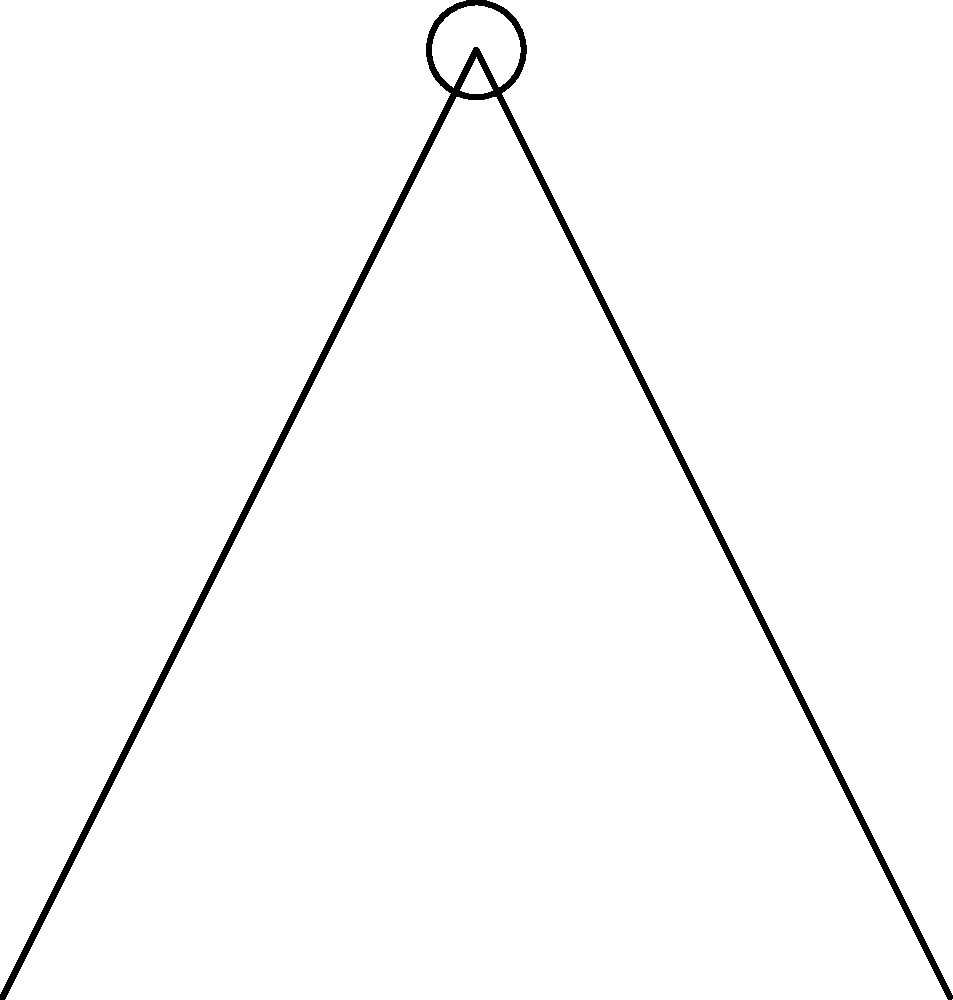As a union leader advocating for worker safety, you're analyzing the biomechanics of manual material handling. In the stick figure illustration, a worker is lifting a load. If the worker's hand force (F) is 300 N, the horizontal distance (L) from the ankles to the hands is 0.5 m, and the vertical distance (h) from the floor to the hands is 1 m, what is the magnitude of the moment about the worker's lower back? To solve this problem, we'll follow these steps:

1. Understand the concept of moment:
   Moment = Force × Perpendicular distance

2. Identify the given information:
   - Hand force (F) = 300 N
   - Horizontal distance (L) = 0.5 m
   - Vertical distance (h) = 1 m

3. Determine the perpendicular distance:
   In this case, the perpendicular distance is the horizontal distance (L) from the ankles to the hands.

4. Calculate the moment:
   Moment = F × L
   Moment = 300 N × 0.5 m
   Moment = 150 N·m

5. Interpret the result:
   The moment about the worker's lower back is 150 N·m, which represents the rotational force acting on the lower back during the lifting task.

This analysis helps in understanding the stress on the worker's back during manual material handling, which is crucial for developing safe work practices and ergonomic guidelines.
Answer: 150 N·m 